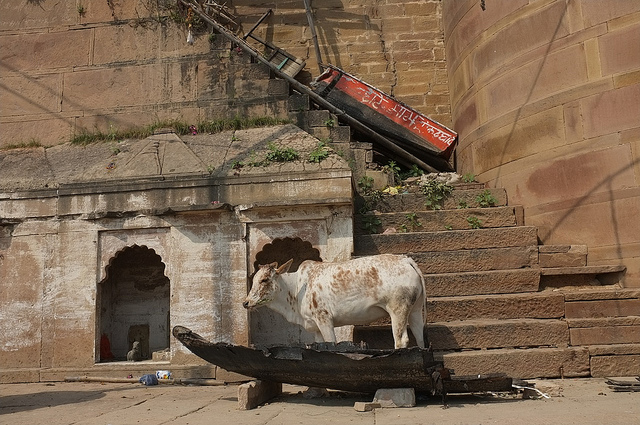What color is the cow? The cow is primarily white with substantial brown patches over its body, creating a distinctive pattern. 